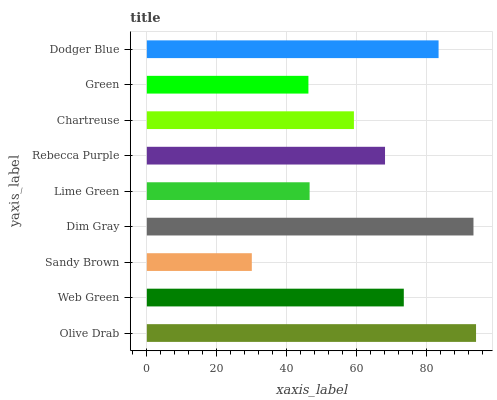Is Sandy Brown the minimum?
Answer yes or no. Yes. Is Olive Drab the maximum?
Answer yes or no. Yes. Is Web Green the minimum?
Answer yes or no. No. Is Web Green the maximum?
Answer yes or no. No. Is Olive Drab greater than Web Green?
Answer yes or no. Yes. Is Web Green less than Olive Drab?
Answer yes or no. Yes. Is Web Green greater than Olive Drab?
Answer yes or no. No. Is Olive Drab less than Web Green?
Answer yes or no. No. Is Rebecca Purple the high median?
Answer yes or no. Yes. Is Rebecca Purple the low median?
Answer yes or no. Yes. Is Green the high median?
Answer yes or no. No. Is Olive Drab the low median?
Answer yes or no. No. 